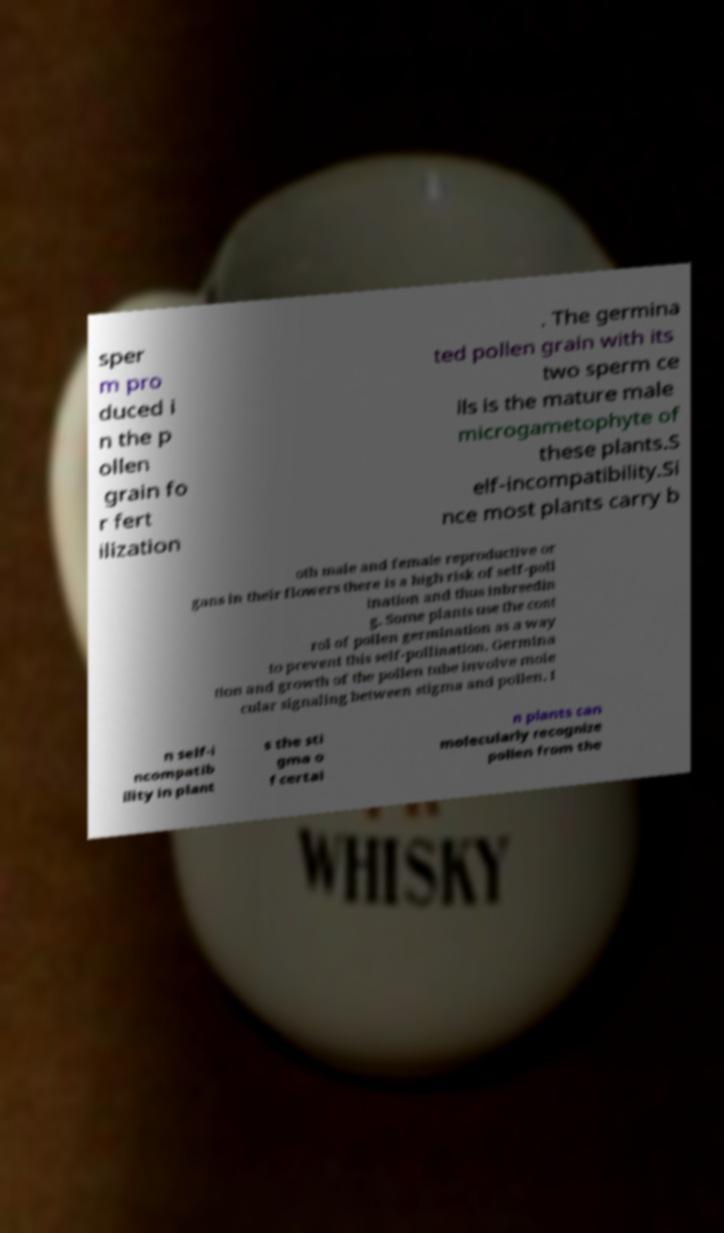What messages or text are displayed in this image? I need them in a readable, typed format. sper m pro duced i n the p ollen grain fo r fert ilization . The germina ted pollen grain with its two sperm ce lls is the mature male microgametophyte of these plants.S elf-incompatibility.Si nce most plants carry b oth male and female reproductive or gans in their flowers there is a high risk of self-poll ination and thus inbreedin g. Some plants use the cont rol of pollen germination as a way to prevent this self-pollination. Germina tion and growth of the pollen tube involve mole cular signaling between stigma and pollen. I n self-i ncompatib ility in plant s the sti gma o f certai n plants can molecularly recognize pollen from the 